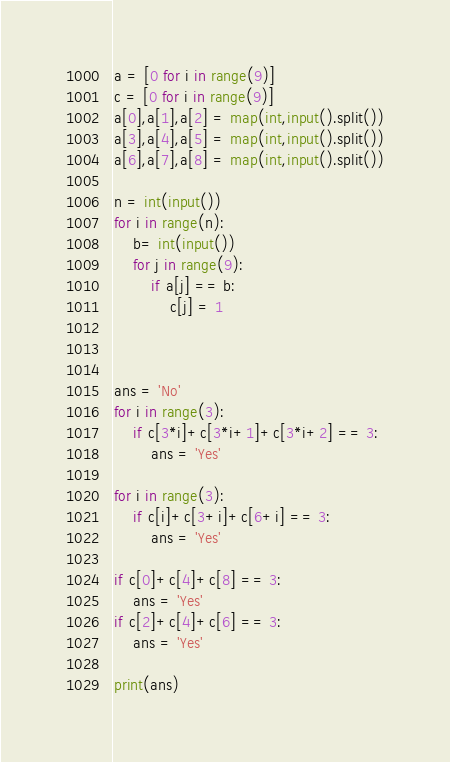Convert code to text. <code><loc_0><loc_0><loc_500><loc_500><_Python_>a = [0 for i in range(9)]
c = [0 for i in range(9)]
a[0],a[1],a[2] = map(int,input().split())
a[3],a[4],a[5] = map(int,input().split())
a[6],a[7],a[8] = map(int,input().split())

n = int(input())
for i in range(n):
    b= int(input())
    for j in range(9):
        if a[j] == b:
            c[j] = 1



ans = 'No'
for i in range(3):
    if c[3*i]+c[3*i+1]+c[3*i+2] == 3:
        ans = 'Yes'

for i in range(3):
    if c[i]+c[3+i]+c[6+i] == 3:
        ans = 'Yes'

if c[0]+c[4]+c[8] == 3:
    ans = 'Yes'
if c[2]+c[4]+c[6] == 3:
    ans = 'Yes'

print(ans)</code> 